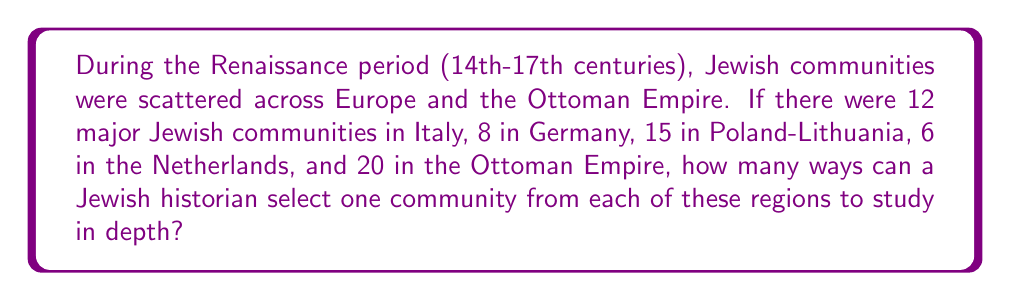Show me your answer to this math problem. To solve this problem, we need to apply the multiplication principle of counting. This principle states that if we have a sequence of independent choices, where there are $m_1$ ways of making the first choice, $m_2$ ways of making the second choice, and so on up to $m_k$ ways of making the $k$-th choice, then the total number of ways to make all these choices is the product $m_1 \times m_2 \times ... \times m_k$.

In this case, we have 5 independent choices (one for each region):

1. Italy: 12 choices
2. Germany: 8 choices
3. Poland-Lithuania: 15 choices
4. Netherlands: 6 choices
5. Ottoman Empire: 20 choices

Therefore, the total number of ways to select one community from each region is:

$$12 \times 8 \times 15 \times 6 \times 20$$

We can calculate this product:
$$12 \times 8 = 96$$
$$96 \times 15 = 1,440$$
$$1,440 \times 6 = 8,640$$
$$8,640 \times 20 = 172,800$$

Thus, there are 172,800 different ways for a Jewish historian to select one community from each of these regions to study in depth.
Answer: 172,800 